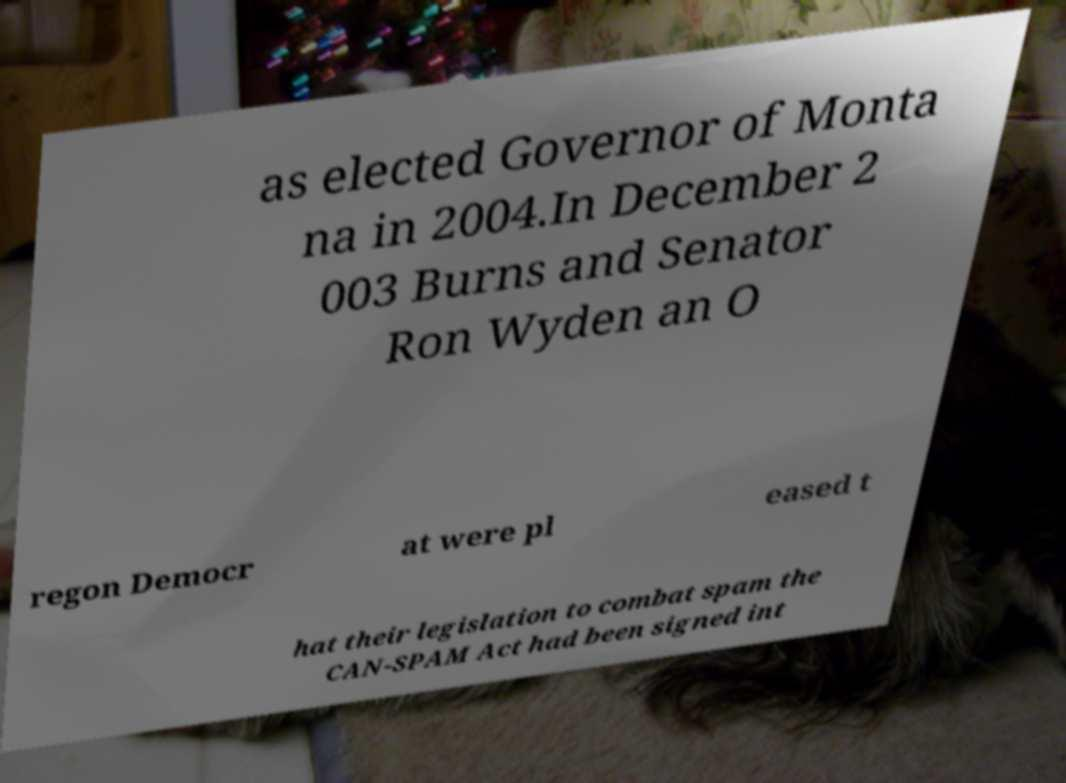There's text embedded in this image that I need extracted. Can you transcribe it verbatim? as elected Governor of Monta na in 2004.In December 2 003 Burns and Senator Ron Wyden an O regon Democr at were pl eased t hat their legislation to combat spam the CAN-SPAM Act had been signed int 